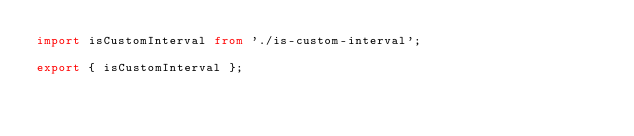<code> <loc_0><loc_0><loc_500><loc_500><_TypeScript_>import isCustomInterval from './is-custom-interval';

export { isCustomInterval };
</code> 